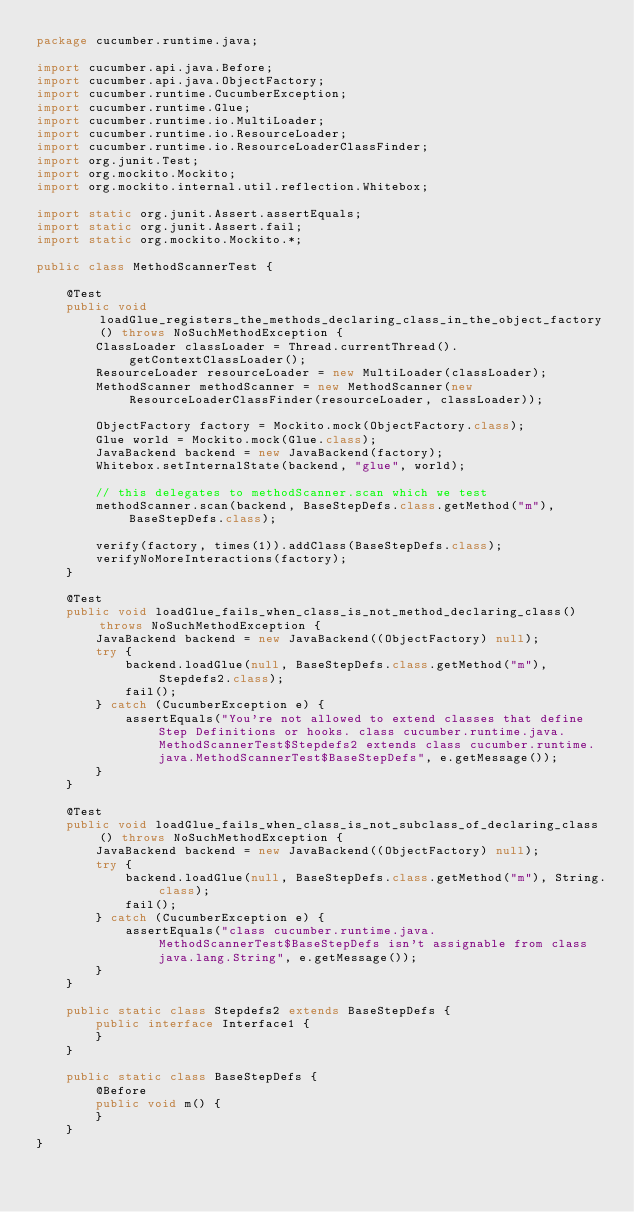Convert code to text. <code><loc_0><loc_0><loc_500><loc_500><_Java_>package cucumber.runtime.java;

import cucumber.api.java.Before;
import cucumber.api.java.ObjectFactory;
import cucumber.runtime.CucumberException;
import cucumber.runtime.Glue;
import cucumber.runtime.io.MultiLoader;
import cucumber.runtime.io.ResourceLoader;
import cucumber.runtime.io.ResourceLoaderClassFinder;
import org.junit.Test;
import org.mockito.Mockito;
import org.mockito.internal.util.reflection.Whitebox;

import static org.junit.Assert.assertEquals;
import static org.junit.Assert.fail;
import static org.mockito.Mockito.*;

public class MethodScannerTest {

    @Test
    public void loadGlue_registers_the_methods_declaring_class_in_the_object_factory() throws NoSuchMethodException {
        ClassLoader classLoader = Thread.currentThread().getContextClassLoader();
        ResourceLoader resourceLoader = new MultiLoader(classLoader);
        MethodScanner methodScanner = new MethodScanner(new ResourceLoaderClassFinder(resourceLoader, classLoader));

        ObjectFactory factory = Mockito.mock(ObjectFactory.class);
        Glue world = Mockito.mock(Glue.class);
        JavaBackend backend = new JavaBackend(factory);
        Whitebox.setInternalState(backend, "glue", world);

        // this delegates to methodScanner.scan which we test
        methodScanner.scan(backend, BaseStepDefs.class.getMethod("m"), BaseStepDefs.class);

        verify(factory, times(1)).addClass(BaseStepDefs.class);
        verifyNoMoreInteractions(factory);
    }

    @Test
    public void loadGlue_fails_when_class_is_not_method_declaring_class() throws NoSuchMethodException {
        JavaBackend backend = new JavaBackend((ObjectFactory) null);
        try {
            backend.loadGlue(null, BaseStepDefs.class.getMethod("m"), Stepdefs2.class);
            fail();
        } catch (CucumberException e) {
            assertEquals("You're not allowed to extend classes that define Step Definitions or hooks. class cucumber.runtime.java.MethodScannerTest$Stepdefs2 extends class cucumber.runtime.java.MethodScannerTest$BaseStepDefs", e.getMessage());
        }
    }

    @Test
    public void loadGlue_fails_when_class_is_not_subclass_of_declaring_class() throws NoSuchMethodException {
        JavaBackend backend = new JavaBackend((ObjectFactory) null);
        try {
            backend.loadGlue(null, BaseStepDefs.class.getMethod("m"), String.class);
            fail();
        } catch (CucumberException e) {
            assertEquals("class cucumber.runtime.java.MethodScannerTest$BaseStepDefs isn't assignable from class java.lang.String", e.getMessage());
        }
    }

    public static class Stepdefs2 extends BaseStepDefs {
        public interface Interface1 {
        }
    }

    public static class BaseStepDefs {
        @Before
        public void m() {
        }
    }
}
</code> 